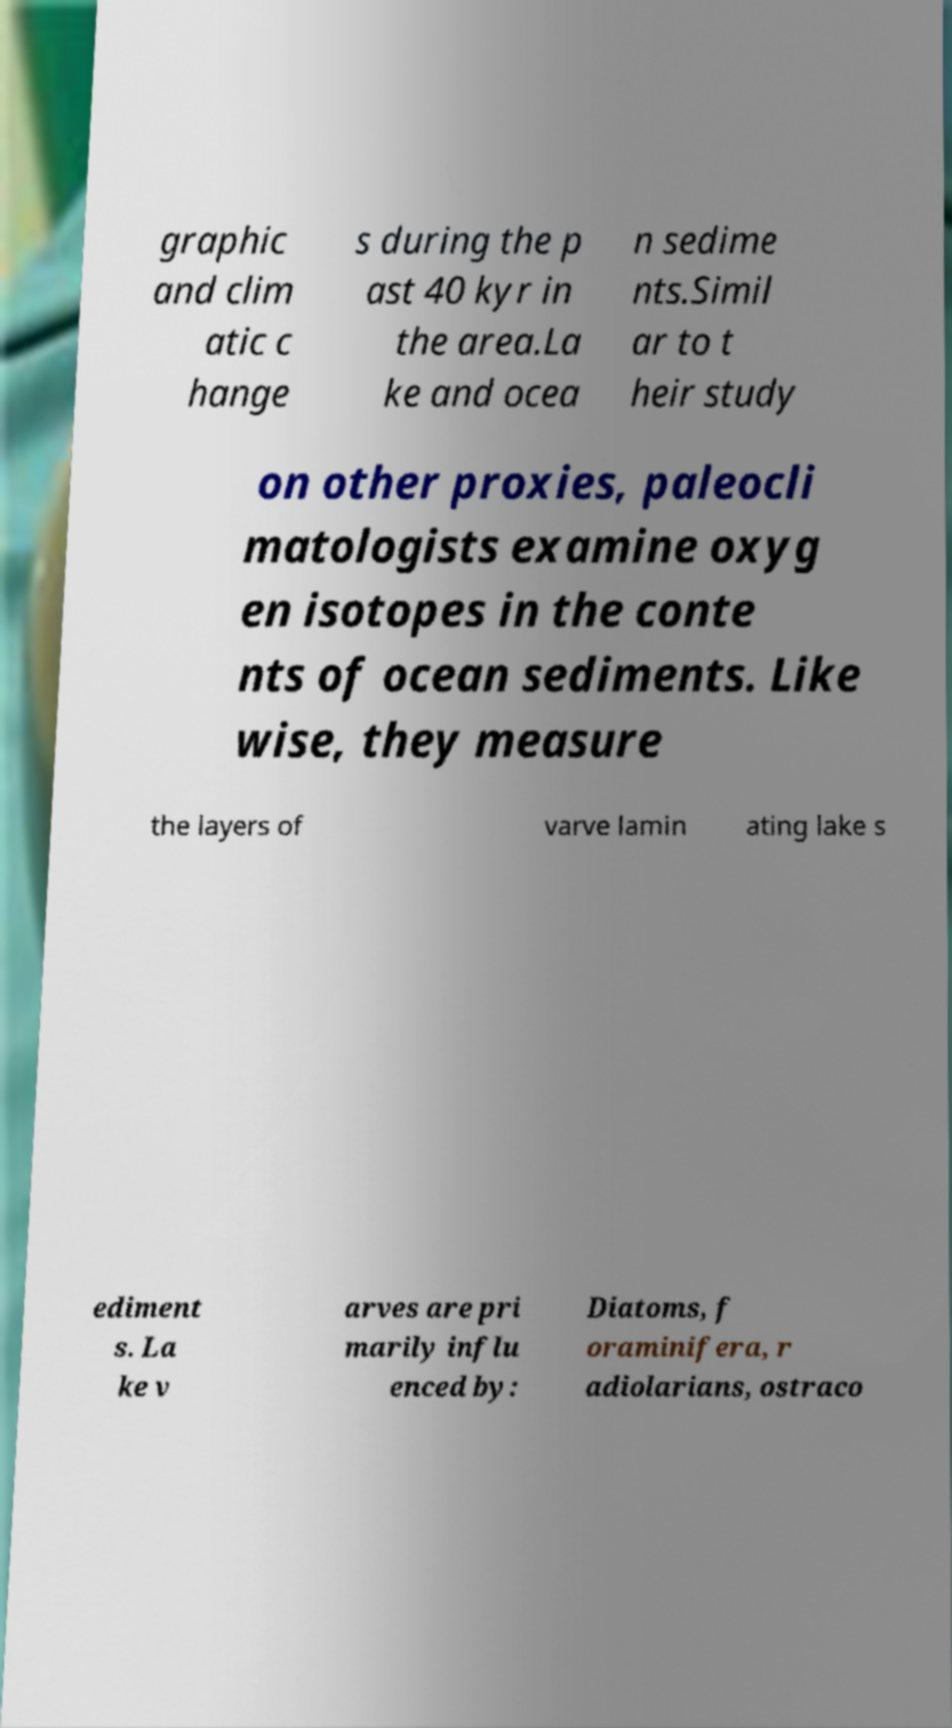Could you assist in decoding the text presented in this image and type it out clearly? graphic and clim atic c hange s during the p ast 40 kyr in the area.La ke and ocea n sedime nts.Simil ar to t heir study on other proxies, paleocli matologists examine oxyg en isotopes in the conte nts of ocean sediments. Like wise, they measure the layers of varve lamin ating lake s ediment s. La ke v arves are pri marily influ enced by: Diatoms, f oraminifera, r adiolarians, ostraco 